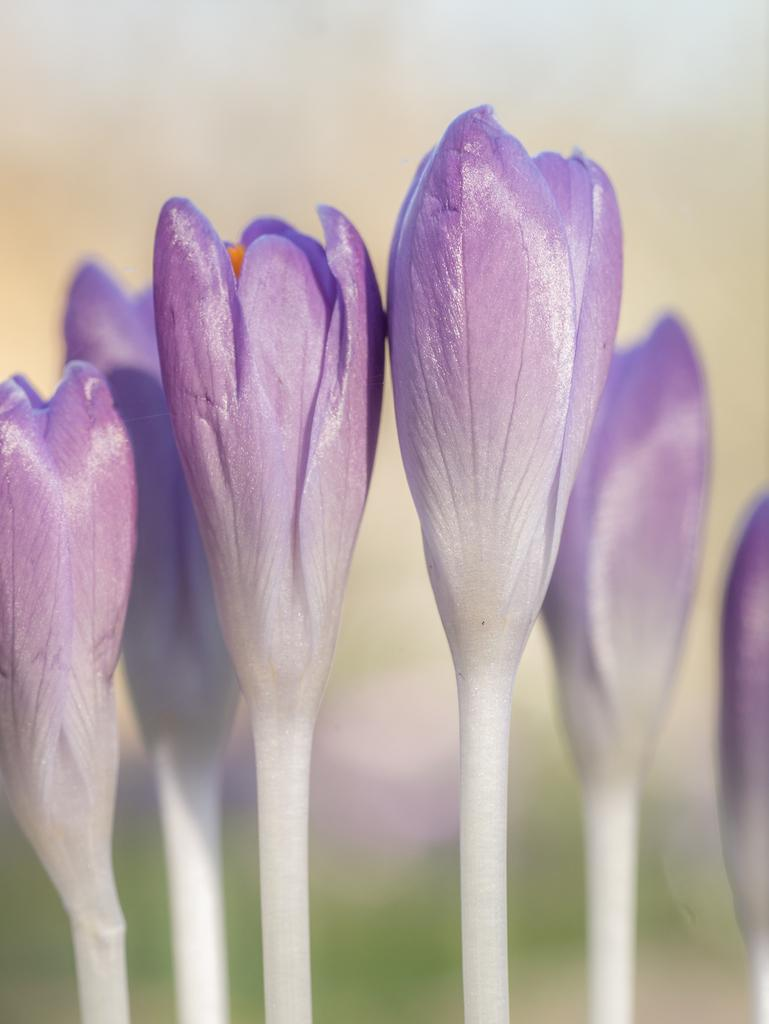What is present in the image? There are flowers in the image. Can you describe the background of the image? The background of the image is blurred. Where is the cart located in the image? There is no cart present in the image. Who is the expert in the image? There is no expert present in the image. 